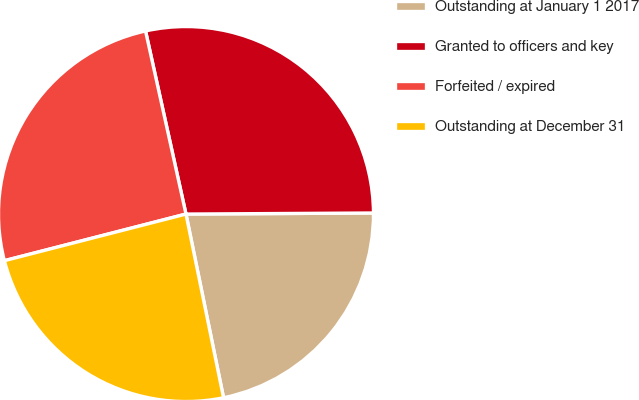Convert chart to OTSL. <chart><loc_0><loc_0><loc_500><loc_500><pie_chart><fcel>Outstanding at January 1 2017<fcel>Granted to officers and key<fcel>Forfeited / expired<fcel>Outstanding at December 31<nl><fcel>21.88%<fcel>28.37%<fcel>25.54%<fcel>24.21%<nl></chart> 